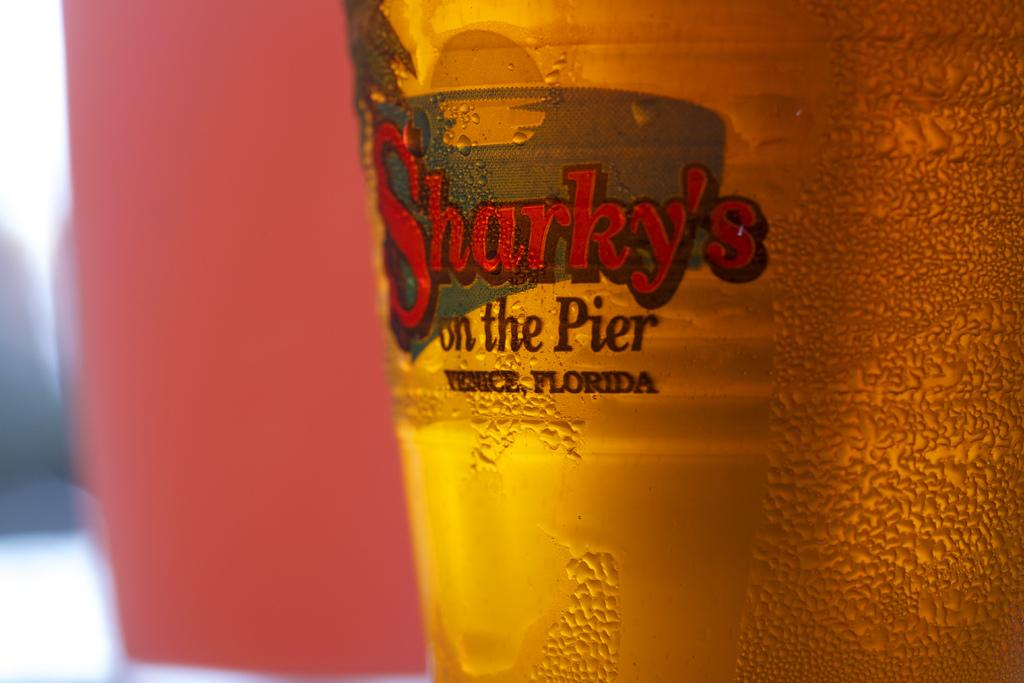<image>
Relay a brief, clear account of the picture shown. The glass of Sharky's On The Pier is full 